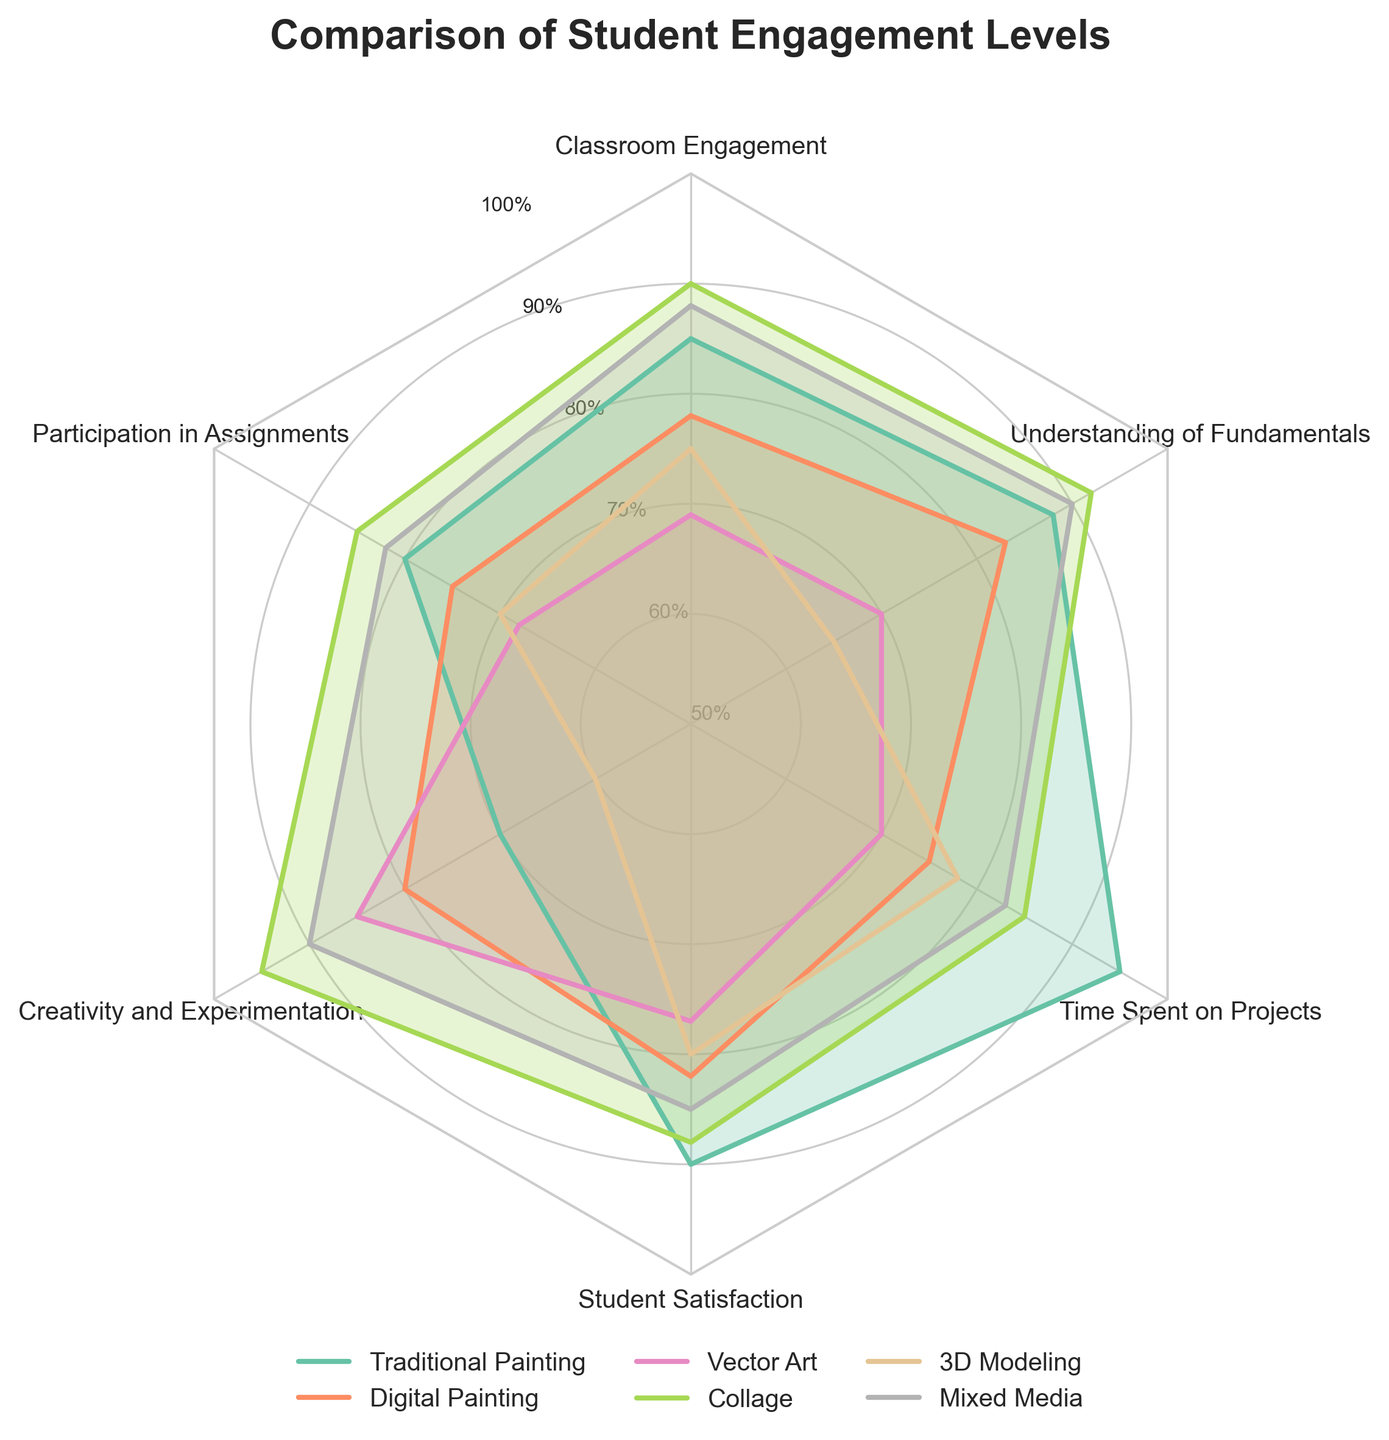What is the title of the radar chart? The title is usually displayed at the top of the chart. When viewing the figure, you will see "Comparison of Student Engagement Levels" prominently displayed.
Answer: Comparison of Student Engagement Levels Which technique shows the highest student satisfaction? Look for the "Student Satisfaction" axis and compare the values for each technique. The highest point on this axis is for "Traditional Painting" at 90%.
Answer: Traditional Painting Compare the creativity and experimentation levels between Vector Art and 3D Modeling. Which one is higher? On the "Creativity and Experimentation" axis, find the values for both techniques. Vector Art has an 85% rating, while 3D Modeling has a 60% rating.
Answer: Vector Art Which technique has the lowest time spent on projects? Locate the "Time Spent on Projects" axis and identify the smallest value. "Digital Painting" is the lowest at 75%.
Answer: Digital Painting Are the engagement levels for Collage and Mixed Media higher in Creativity and Experimentation than in Classroom Engagement? Compare the values for Creativity and Experimentation with Classroom Engagement for each technique. For Collage, Creativity and Experimentation is 95%, and Classroom Engagement is 90%. For Mixed Media, it's 90% and 88% respectively.
Answer: Yes What is the average participation in assignments level for Collage, 3D Modeling, and Mixed Media? Calculate the average by adding the values for Collage (85%), 3D Modeling (70%), and Mixed Media (82%), then divide by 3: (85 + 70 + 82) / 3 = 79%.
Answer: 79% Which technique shows the greatest variety in scores across the different metrics? Assess the fluctuation of scores for each technique by observing their spread across different axes. The greatest variety appears in "3D Modeling" with a range from 60% to 92%.
Answer: 3D Modeling How do participation in assignments for Digital Painting and Vector Art compare? Look at the "Participation in Assignments" axis and note the values: Digital Painting is 75%, and Vector Art is 68%. Digital Painting is higher.
Answer: Digital Painting What is the maximum value for time spent on projects? This can be seen on the "Time Spent on Projects" axis. The maximum value is for Traditional Painting at 95%.
Answer: 95% Is there any technique that scores uniformly across all metrics? Check for any technique that has the same value across all axes. All techniques exhibit varying scores across different metrics. None are uniform.
Answer: No 